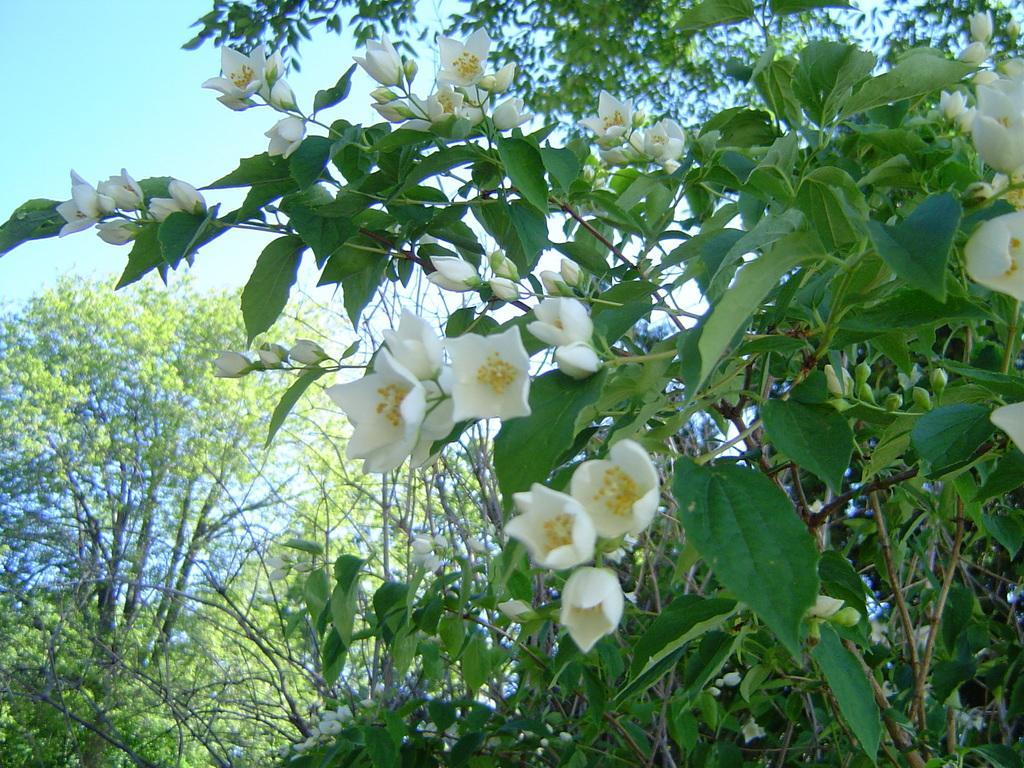Describe this image in one or two sentences. In this picture there are white colored flowers and buds on the plant. At the back there are trees. At the top there is sky. 